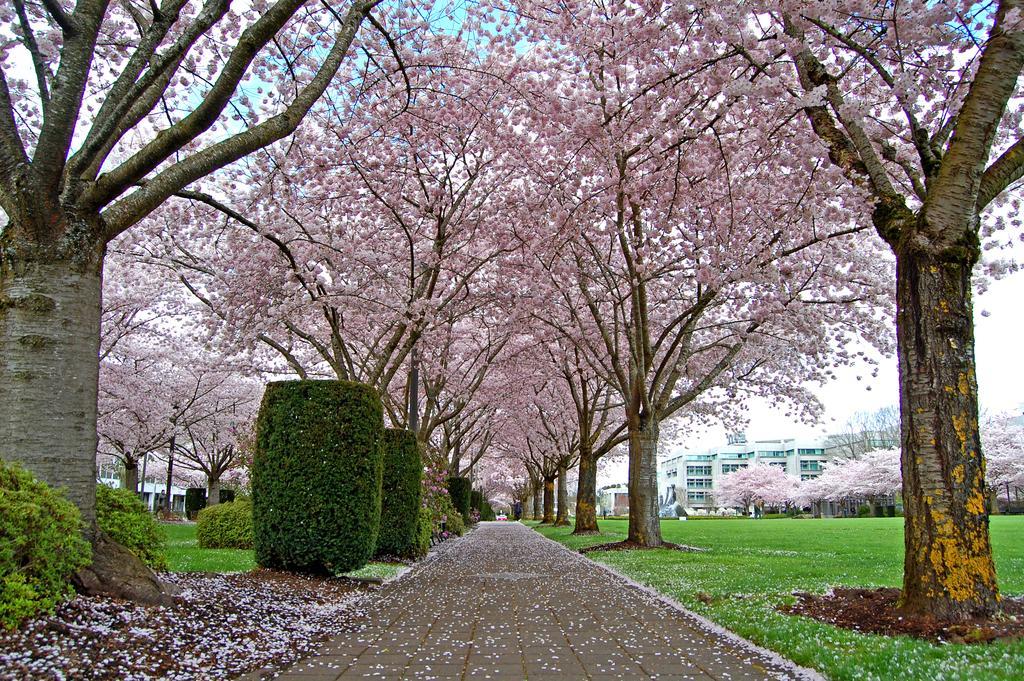Please provide a concise description of this image. In this image we can see few trees with flowers, there are plants and flowers on the road and grass, in the background there are few buildings and the sky. 